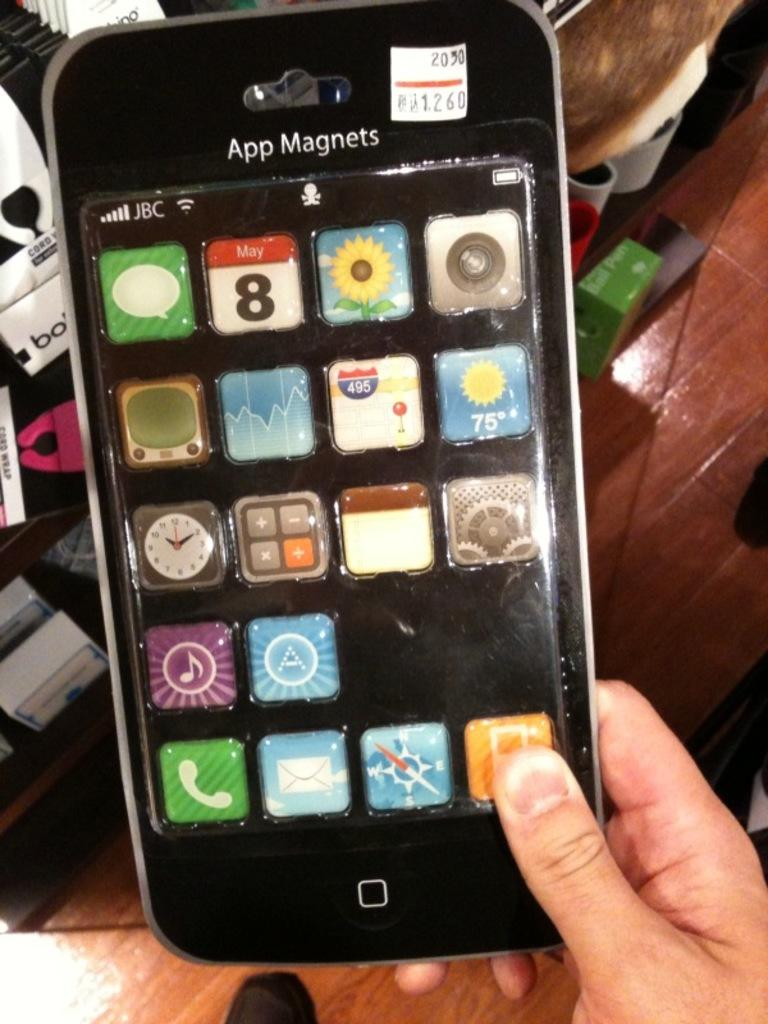<image>
Give a short and clear explanation of the subsequent image. A person is holding a package of App Magnets that looks like a phone. 